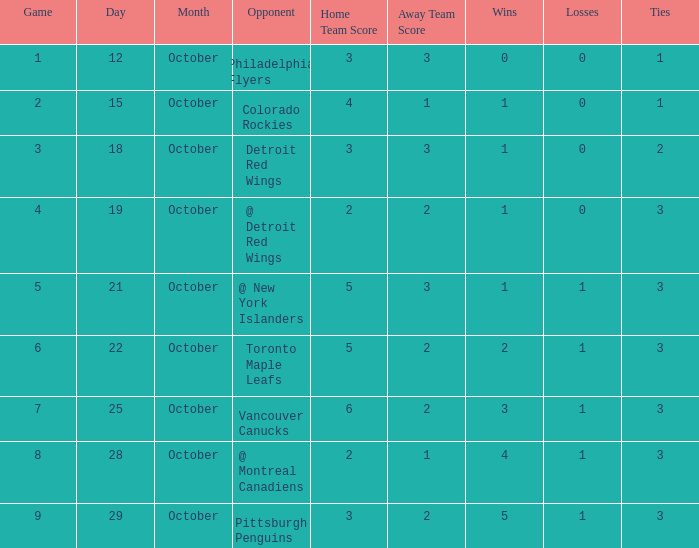Name the score for game more than 6 and before october 28 6 - 2. 